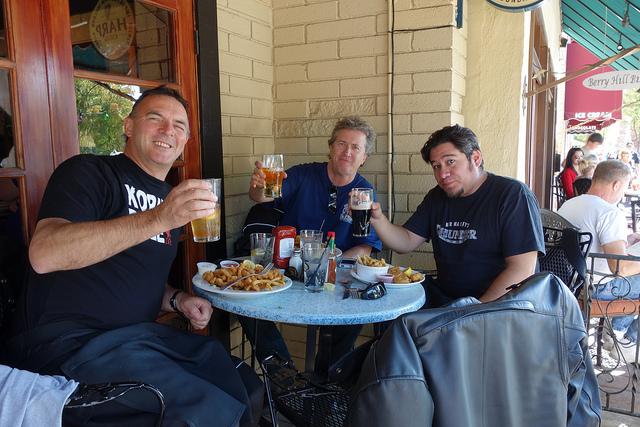Are there any women at the table?
Write a very short answer. No. Is this a log cabin?
Keep it brief. No. What is the color of the brick?
Answer briefly. Yellow. What are the men holding?
Give a very brief answer. Beer. What are these people doing?
Answer briefly. Toasting. What food dish are the soldiers eating?
Give a very brief answer. Fries. What is the man in the middle of the picture doing?
Short answer required. Holding glass. 